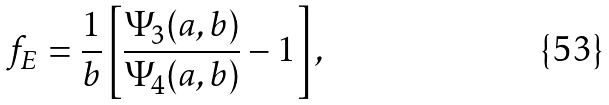Convert formula to latex. <formula><loc_0><loc_0><loc_500><loc_500>f _ { E } = \frac { 1 } { b } \left [ \frac { \Psi _ { 3 } ( a , b ) } { \Psi _ { 4 } ( a , b ) } - 1 \right ] ,</formula> 